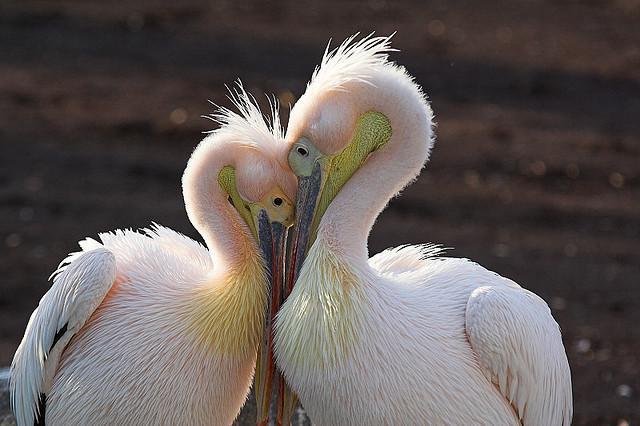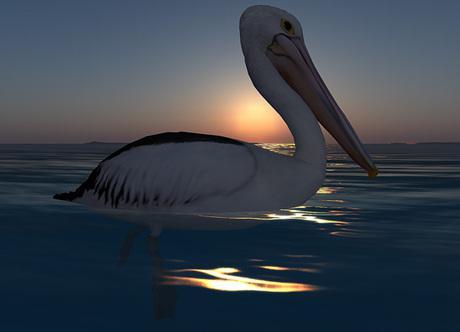The first image is the image on the left, the second image is the image on the right. Analyze the images presented: Is the assertion "The bird in the left image that is furthest to the left is facing towards the left." valid? Answer yes or no. No. The first image is the image on the left, the second image is the image on the right. Examine the images to the left and right. Is the description "The images in each set have no more than three birds in total." accurate? Answer yes or no. Yes. 